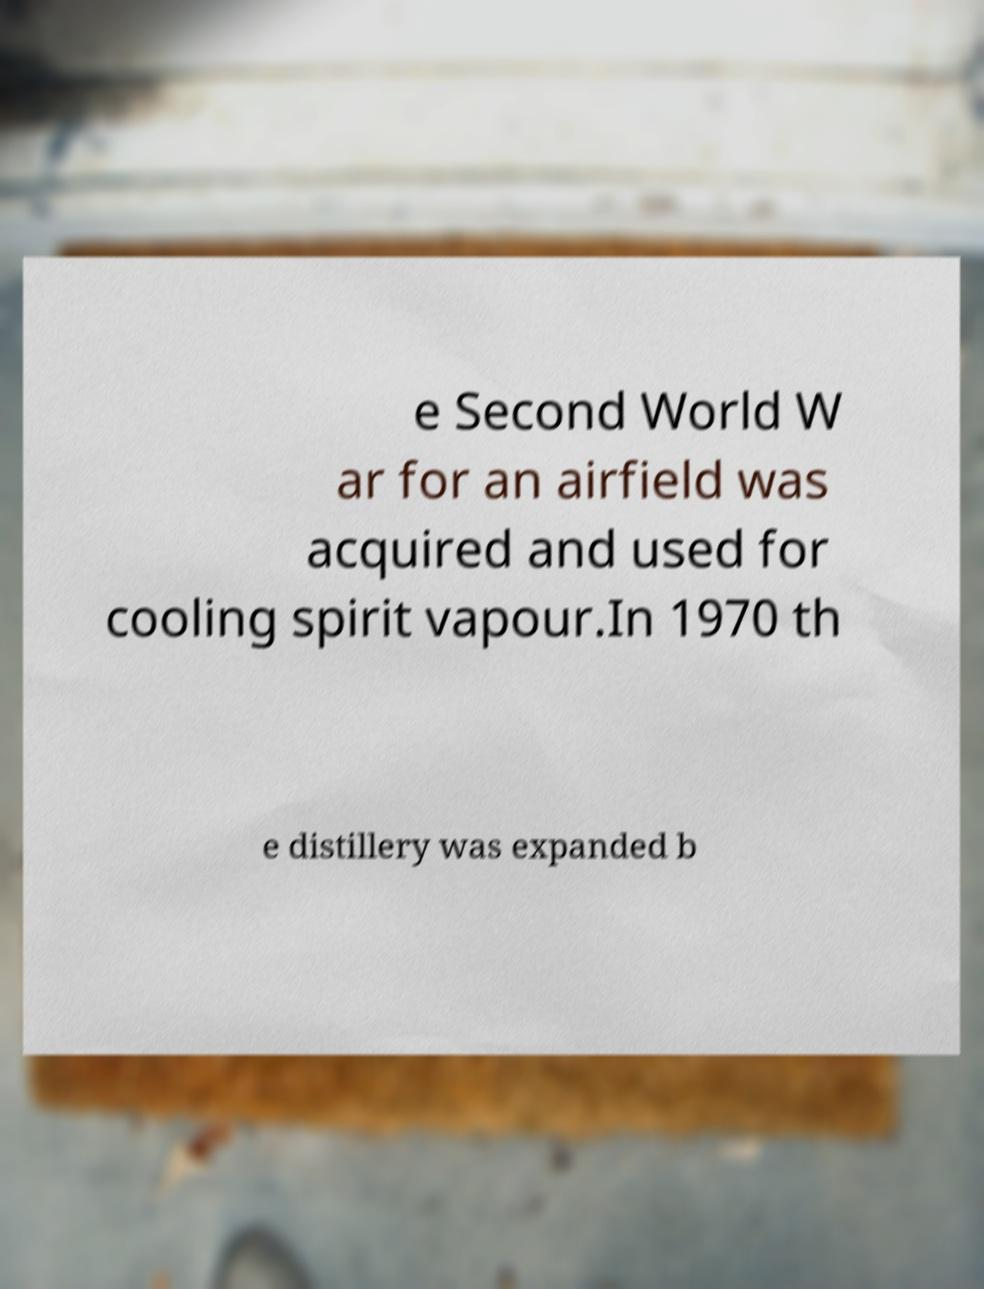Can you accurately transcribe the text from the provided image for me? e Second World W ar for an airfield was acquired and used for cooling spirit vapour.In 1970 th e distillery was expanded b 